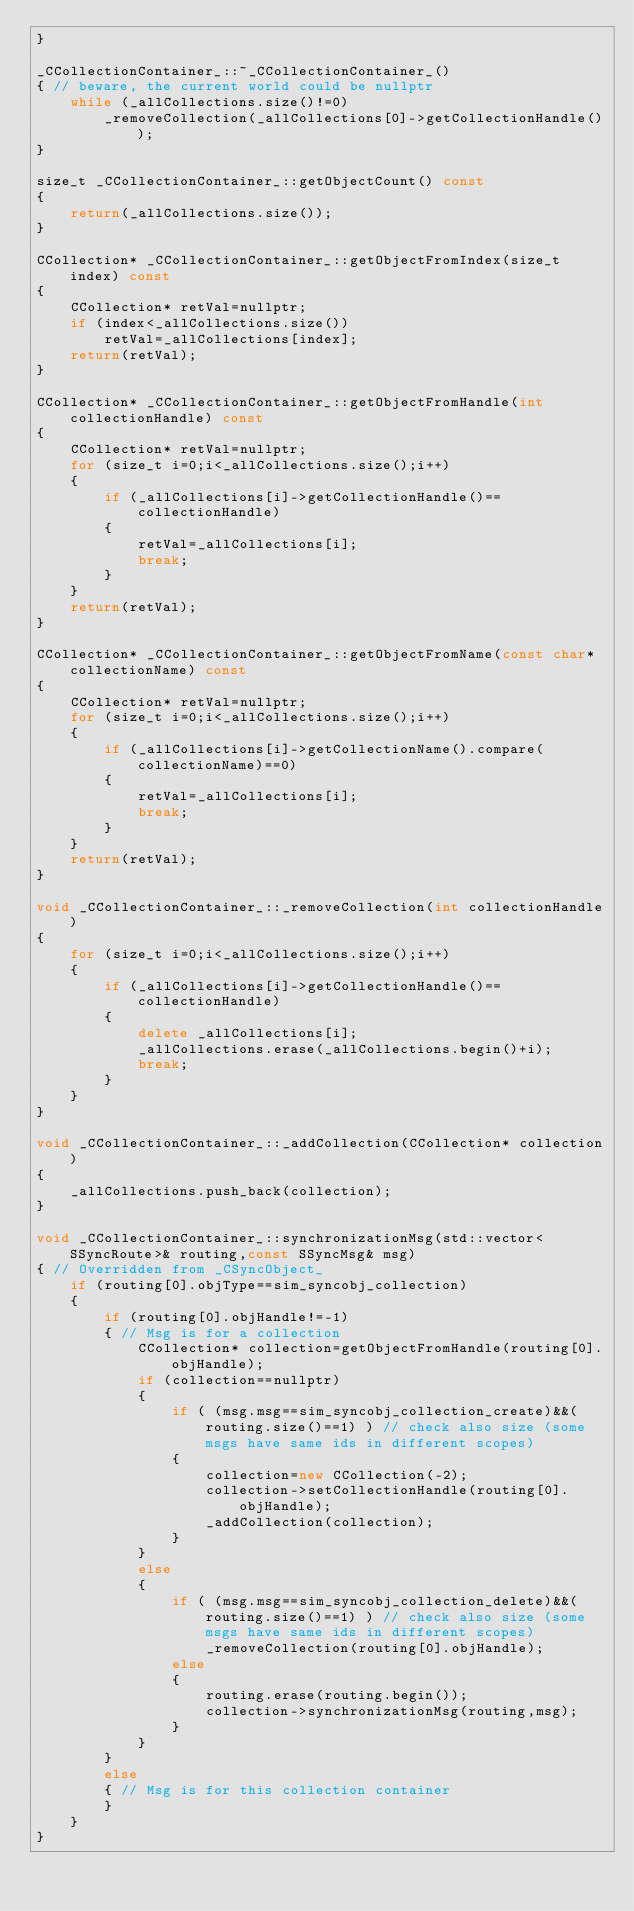Convert code to text. <code><loc_0><loc_0><loc_500><loc_500><_C++_>}

_CCollectionContainer_::~_CCollectionContainer_()
{ // beware, the current world could be nullptr
    while (_allCollections.size()!=0)
        _removeCollection(_allCollections[0]->getCollectionHandle());
}

size_t _CCollectionContainer_::getObjectCount() const
{
    return(_allCollections.size());
}

CCollection* _CCollectionContainer_::getObjectFromIndex(size_t index) const
{
    CCollection* retVal=nullptr;
    if (index<_allCollections.size())
        retVal=_allCollections[index];
    return(retVal);
}

CCollection* _CCollectionContainer_::getObjectFromHandle(int collectionHandle) const
{
    CCollection* retVal=nullptr;
    for (size_t i=0;i<_allCollections.size();i++)
    {
        if (_allCollections[i]->getCollectionHandle()==collectionHandle)
        {
            retVal=_allCollections[i];
            break;
        }
    }
    return(retVal);
}

CCollection* _CCollectionContainer_::getObjectFromName(const char* collectionName) const
{
    CCollection* retVal=nullptr;
    for (size_t i=0;i<_allCollections.size();i++)
    {
        if (_allCollections[i]->getCollectionName().compare(collectionName)==0)
        {
            retVal=_allCollections[i];
            break;
        }
    }
    return(retVal);
}

void _CCollectionContainer_::_removeCollection(int collectionHandle)
{
    for (size_t i=0;i<_allCollections.size();i++)
    {
        if (_allCollections[i]->getCollectionHandle()==collectionHandle)
        {
            delete _allCollections[i];
            _allCollections.erase(_allCollections.begin()+i);
            break;
        }
    }
}

void _CCollectionContainer_::_addCollection(CCollection* collection)
{
    _allCollections.push_back(collection);
}

void _CCollectionContainer_::synchronizationMsg(std::vector<SSyncRoute>& routing,const SSyncMsg& msg)
{ // Overridden from _CSyncObject_
    if (routing[0].objType==sim_syncobj_collection)
    {
        if (routing[0].objHandle!=-1)
        { // Msg is for a collection
            CCollection* collection=getObjectFromHandle(routing[0].objHandle);
            if (collection==nullptr)
            {
                if ( (msg.msg==sim_syncobj_collection_create)&&(routing.size()==1) ) // check also size (some msgs have same ids in different scopes)
                {
                    collection=new CCollection(-2);
                    collection->setCollectionHandle(routing[0].objHandle);
                    _addCollection(collection);
                }
            }
            else
            {
                if ( (msg.msg==sim_syncobj_collection_delete)&&(routing.size()==1) ) // check also size (some msgs have same ids in different scopes)
                    _removeCollection(routing[0].objHandle);
                else
                {
                    routing.erase(routing.begin());
                    collection->synchronizationMsg(routing,msg);
                }
            }
        }
        else
        { // Msg is for this collection container
        }
    }
}
</code> 